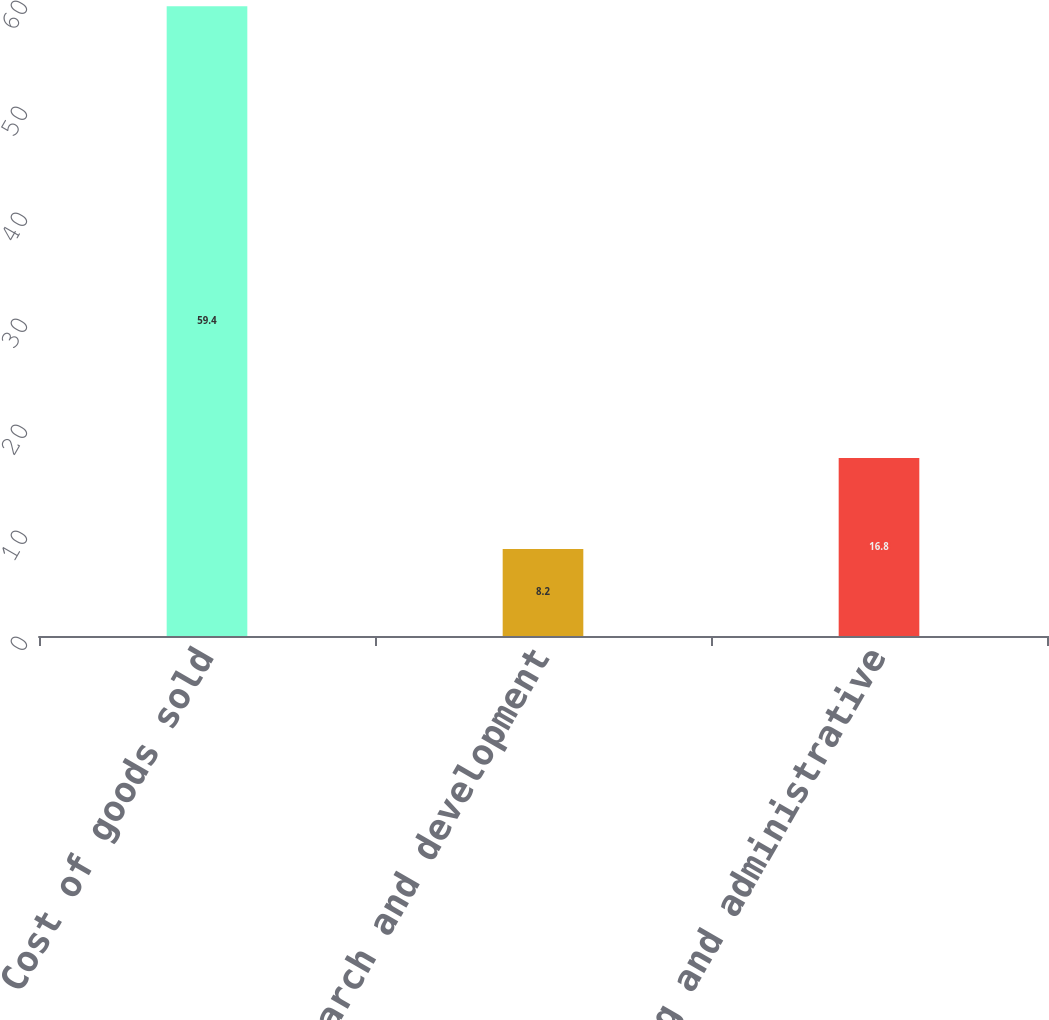Convert chart to OTSL. <chart><loc_0><loc_0><loc_500><loc_500><bar_chart><fcel>Cost of goods sold<fcel>Research and development<fcel>Selling and administrative<nl><fcel>59.4<fcel>8.2<fcel>16.8<nl></chart> 